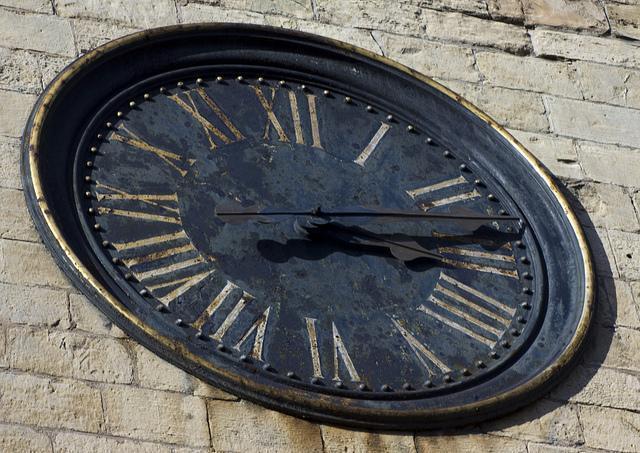How many clocks are there?
Give a very brief answer. 1. 